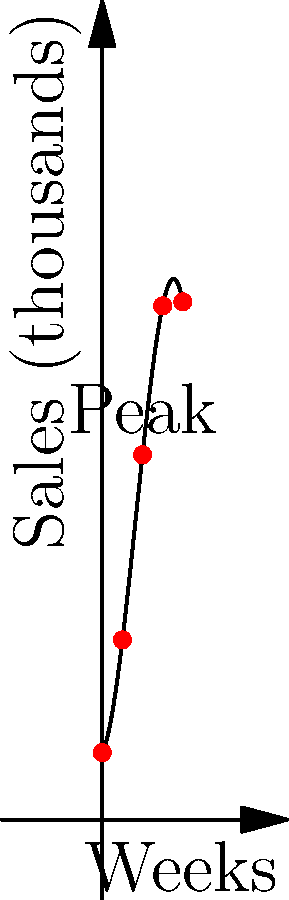The graph shows the sales trend of a new toy line over 12 weeks. What is the approximate week when sales peaked, and what strategy would you recommend for inventory management based on this trend? To answer this question, we need to analyze the polynomial curve represented in the graph:

1. The curve is a cubic polynomial, showing the sales trend over 12 weeks.
2. The y-axis represents sales in thousands, while the x-axis represents weeks.
3. The curve starts at a positive value, increases rapidly, reaches a peak, and then declines.
4. The peak of the curve occurs around week 6, which is clearly labeled on the graph.
5. After the peak, sales decline but remain higher than the initial weeks.

Strategy recommendation based on this trend:
1. Increase inventory rapidly in the first 5 weeks to meet growing demand.
2. Maintain peak inventory levels around weeks 5-7.
3. Gradually reduce inventory after week 7 to avoid overstocking.
4. Consider promotional activities after week 8 to maintain sales and clear remaining stock.
5. Plan for a potential new product introduction or marketing push around week 12 to revitalize interest.
Answer: Peak: Week 6. Strategy: Increase inventory weeks 1-5, maintain peak levels weeks 5-7, gradually reduce after week 7, promote after week 8, plan new product/marketing push around week 12. 